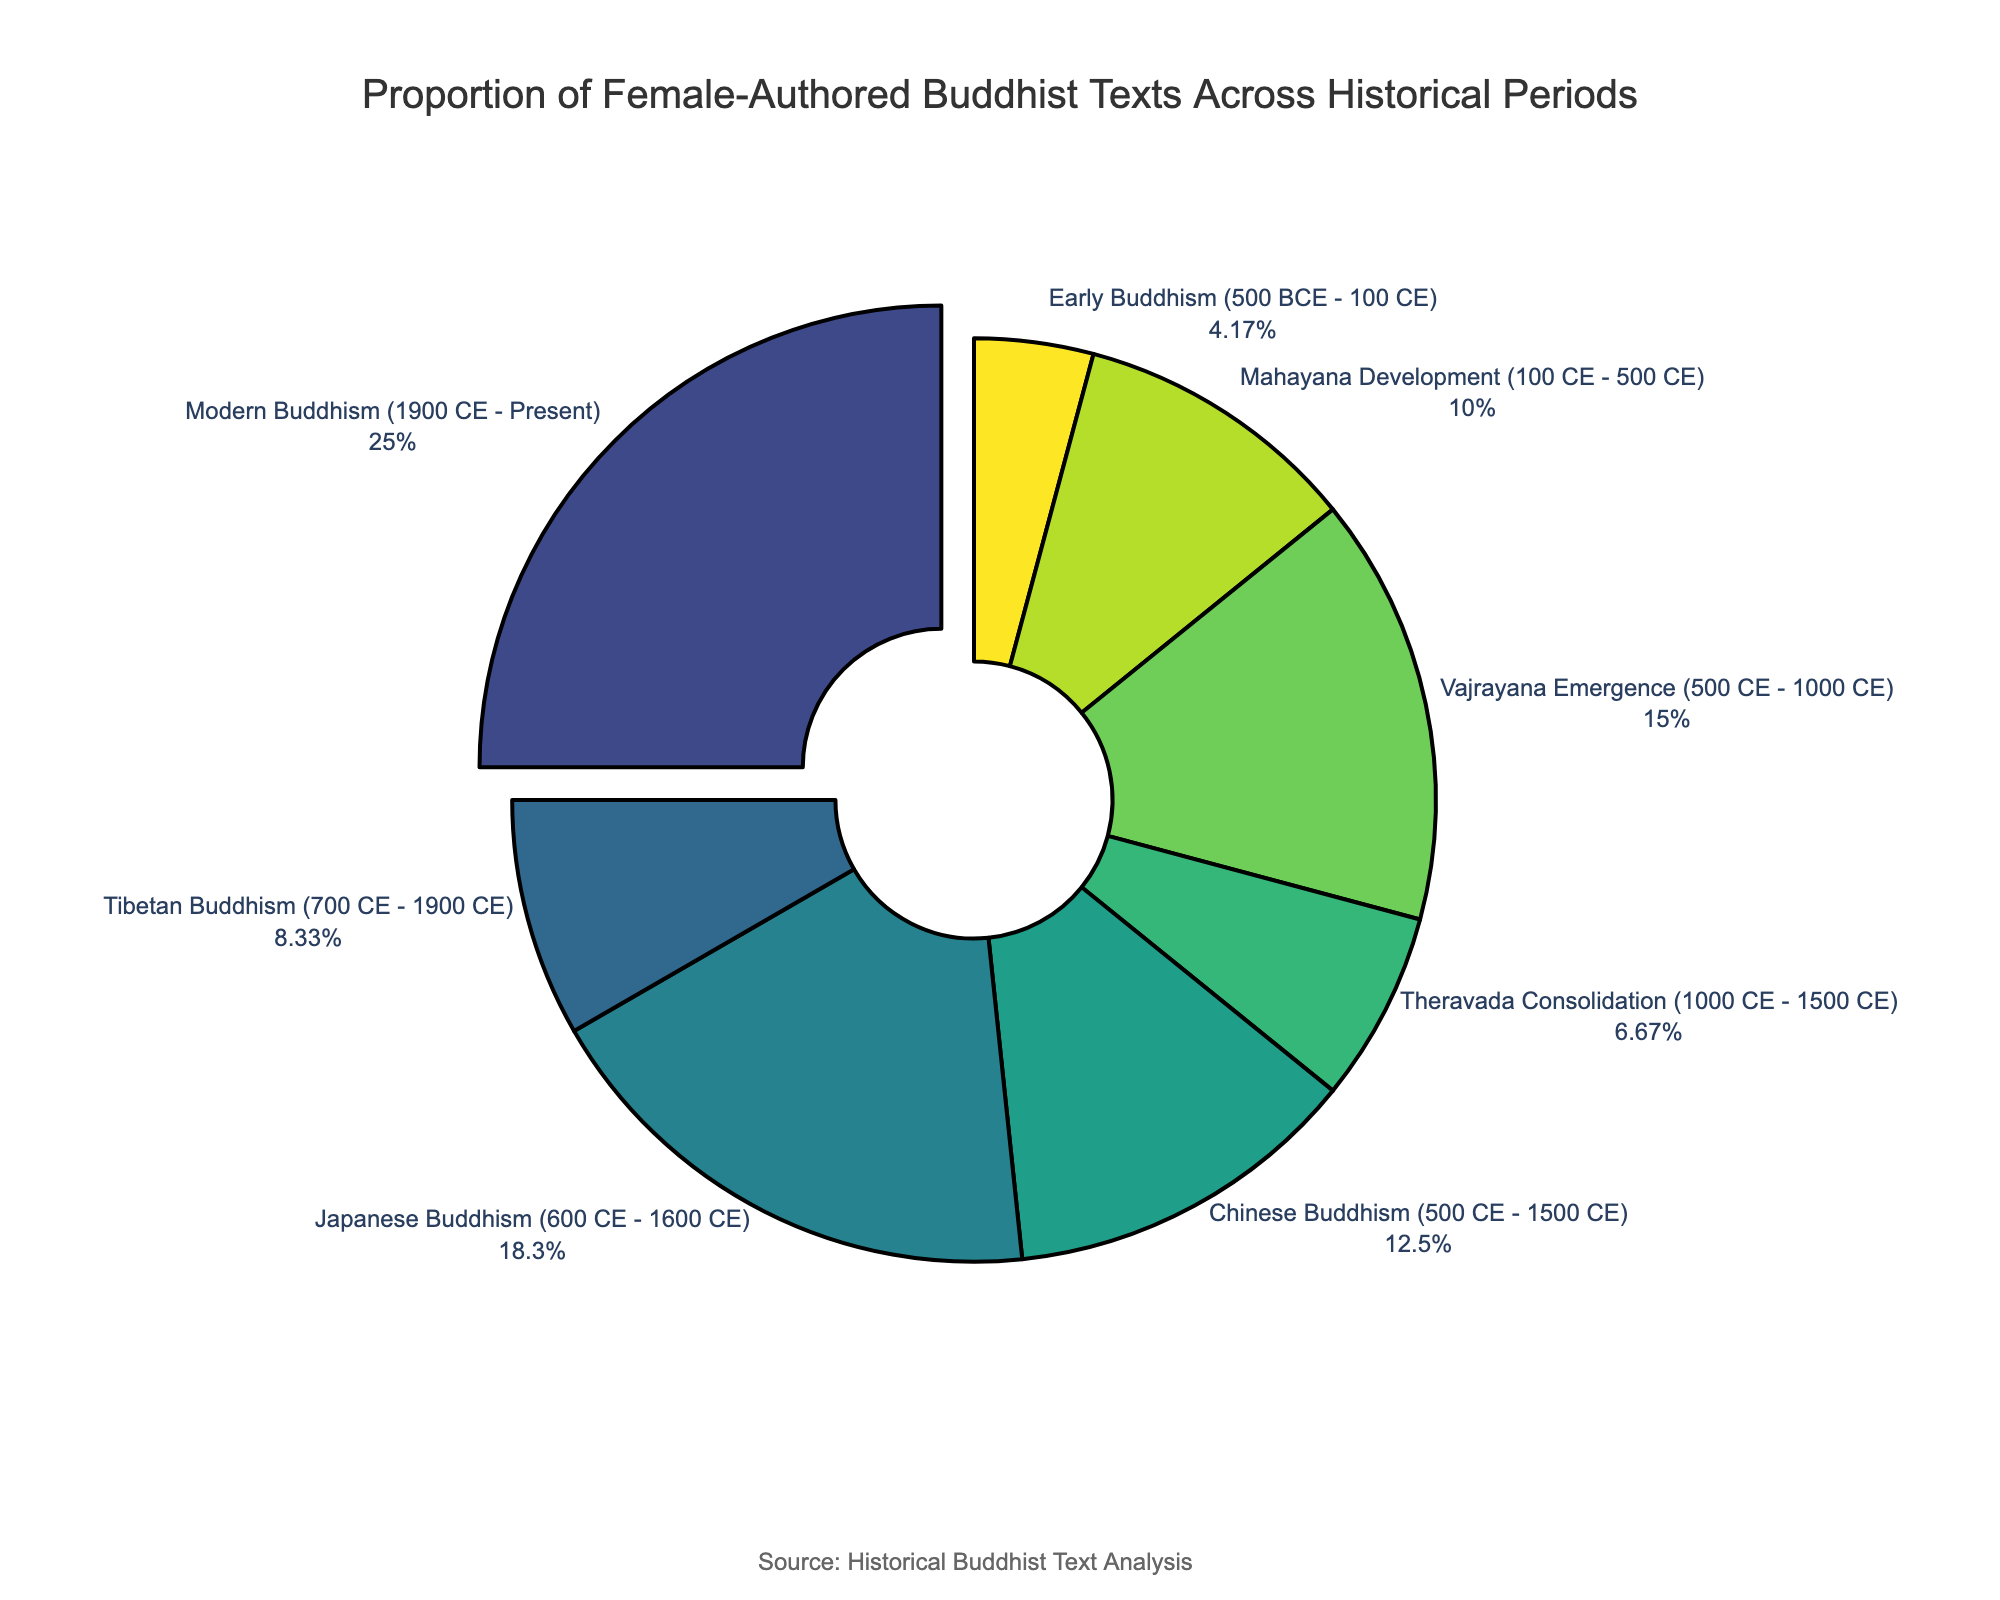Which historical period has the highest proportion of female-authored Buddhist texts? Looking at the pie chart, the segment with the highest percentage is highlighted visually and corresponds to the "Modern Buddhism (1900 CE - Present)" period.
Answer: Modern Buddhism (1900 CE - Present) What is the combined percentage of female-authored texts in the Mahayana Development and Vajrayana Emergence periods? According to the pie chart, Mahayana Development has 12% and Vajrayana Emergence has 18%. Adding these percentages: 12% + 18% = 30%.
Answer: 30% Which historical period has a greater proportion of female-authored texts: Chinese Buddhism or Tibetan Buddhism? By comparing the segments for Chinese Buddhism and Tibetan Buddhism, Chinese Buddhism has 15% and Tibetan Buddhism has 10%. Therefore, Chinese Buddhism has a greater proportion.
Answer: Chinese Buddhism What is the difference in the proportion of female-authored texts between Early Buddhism and Japanese Buddhism? The pie chart shows Early Buddhism with 5% and Japanese Buddhism with 22%. Subtracting these percentages: 22% - 5% = 17%.
Answer: 17% What is the average proportion of female-authored texts across all historical periods? Adding all the percentages: 5% + 12% + 18% + 8% + 15% + 22% + 10% + 30% = 120%. There are 8 periods, so the average is 120% / 8 = 15%.
Answer: 15% Which historical period accounts for the smallest proportion of female-authored Buddhist texts? The smallest segment in the pie chart is labeled with "Early Buddhism (500 BCE - 100 CE)," which shows 5%.
Answer: Early Buddhism (500 BCE - 100 CE) Do Theravada Consolidation and Tibetan Buddhism have a combined proportion higher or lower than Modern Buddhism? Theravada Consolidation has 8% and Tibetan Buddhism has 10%. Summing these gives 18%. Modern Buddhism has 30%. Since 18% < 30%, the combined proportion is lower.
Answer: Lower 